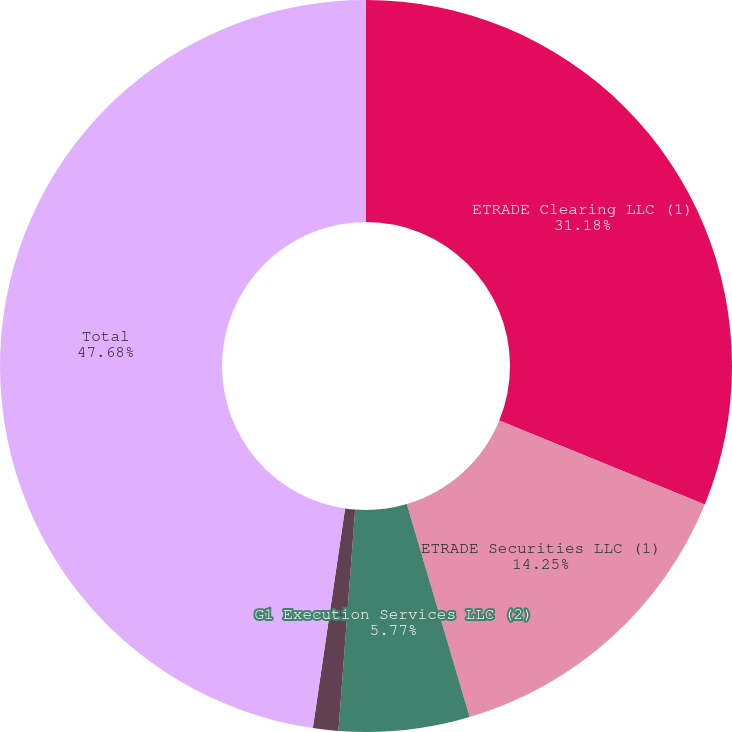Convert chart to OTSL. <chart><loc_0><loc_0><loc_500><loc_500><pie_chart><fcel>ETRADE Clearing LLC (1)<fcel>ETRADE Securities LLC (1)<fcel>G1 Execution Services LLC (2)<fcel>Other broker-dealers<fcel>Total<nl><fcel>31.18%<fcel>14.25%<fcel>5.77%<fcel>1.12%<fcel>47.68%<nl></chart> 